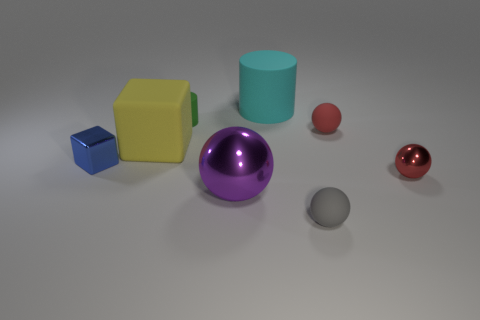There is a block that is the same material as the tiny green object; what is its color? The block sharing the same matte material as the small green sphere is yellow, exhibiting a light, lemon-like shade characteristic of many everyday objects intended to attract attention. 